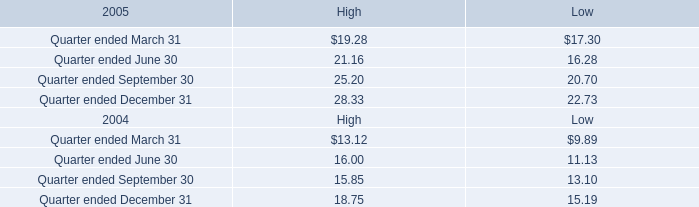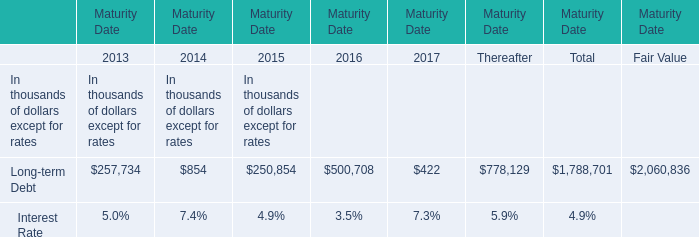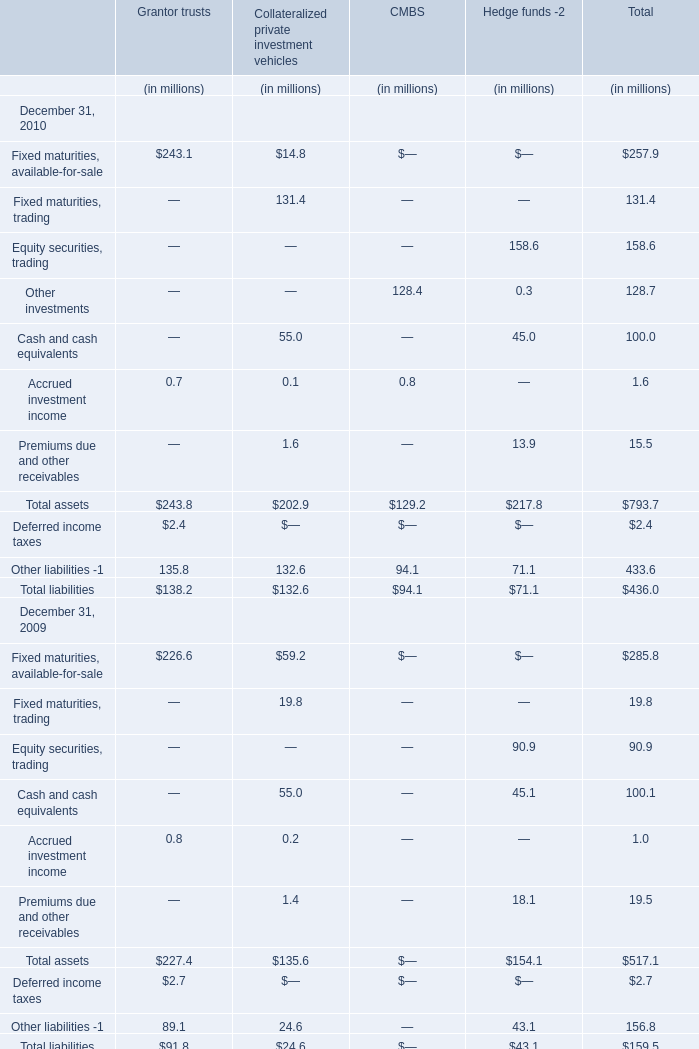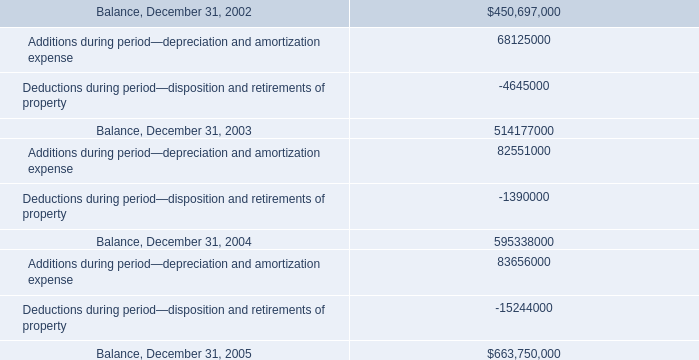what is the increase observed in the balance at the end of the year during 2005 and 2004? 
Computations: ((663750000 / 595338000) - 1)
Answer: 0.11491. 